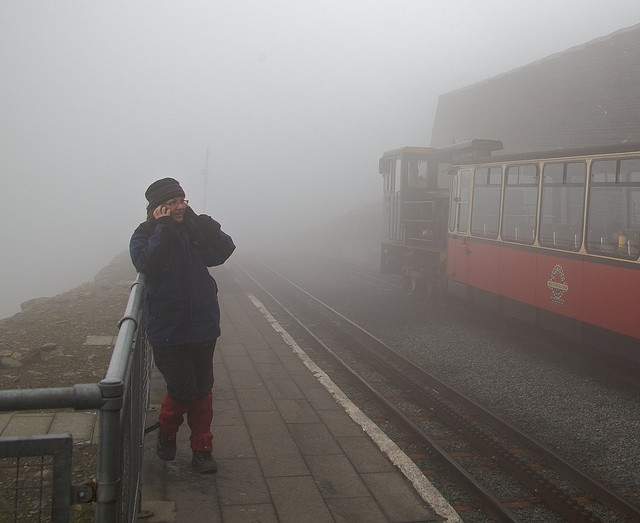Describe the objects in this image and their specific colors. I can see train in lightgray and gray tones, people in lightgray, black, and gray tones, and cell phone in lightgray, brown, and black tones in this image. 